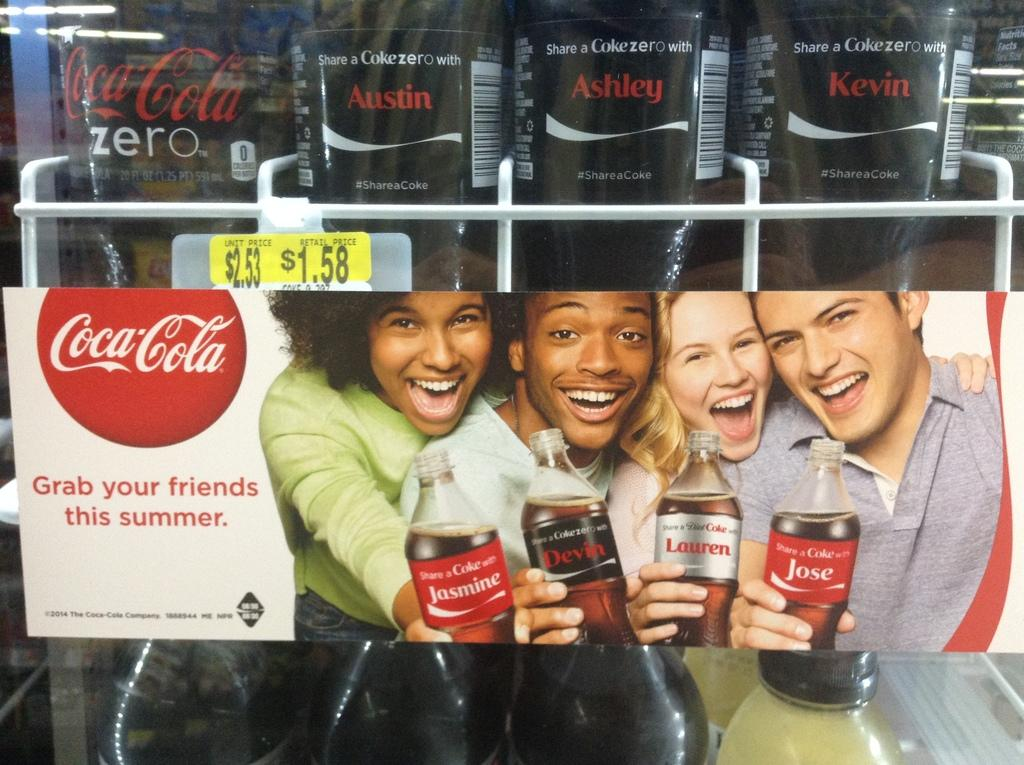Who or what is present in the image? There are people in the image. What are the people holding in their hands? The people are holding bottles. How do the people appear to be feeling in the image? The people have smiles on their faces, indicating that they are happy or enjoying themselves. What type of stone can be seen in the image? There is no stone present in the image; it features people holding bottles and smiling. What season is depicted in the image? The provided facts do not mention any specific season or time of year, so it cannot be determined from the image. 